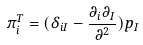Convert formula to latex. <formula><loc_0><loc_0><loc_500><loc_500>\pi _ { i } ^ { T } = ( \delta _ { i I } - \frac { \partial _ { i } \partial _ { I } } { \partial ^ { 2 } } ) p _ { I }</formula> 